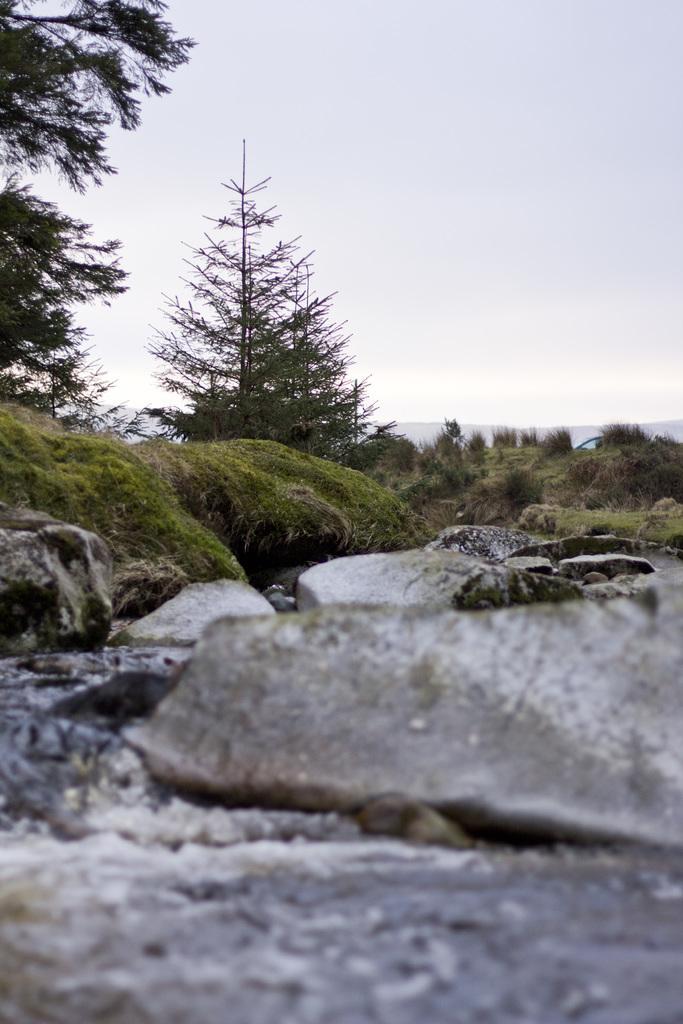Please provide a concise description of this image. This image consists of grass, trees, water, rocks, mountains and the sky. This image taken, maybe during a day. 